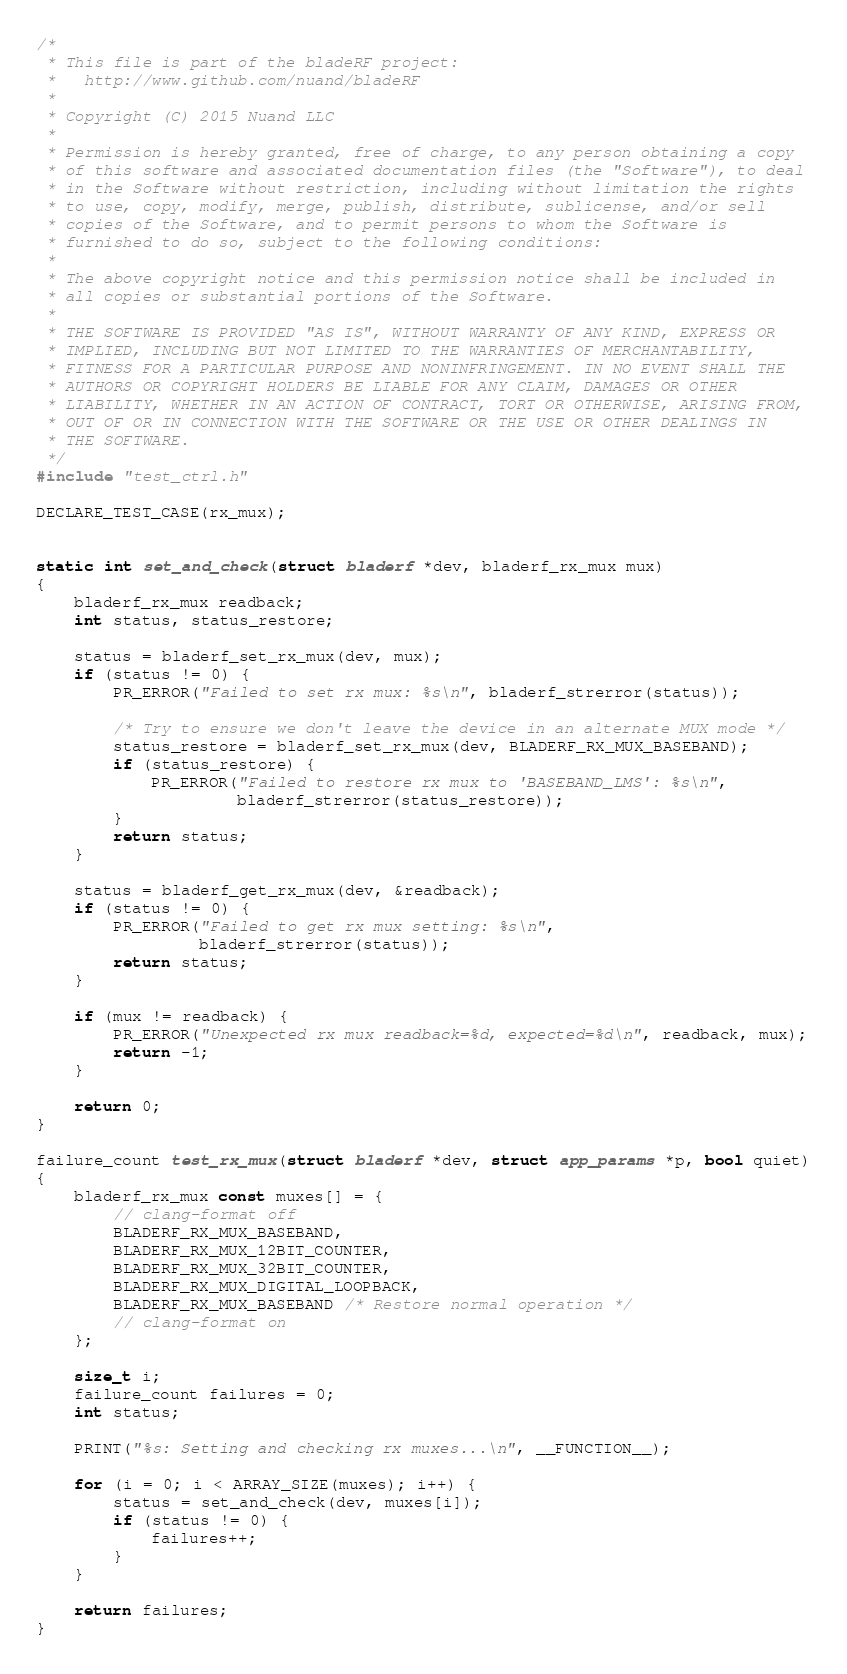<code> <loc_0><loc_0><loc_500><loc_500><_C_>/*
 * This file is part of the bladeRF project:
 *   http://www.github.com/nuand/bladeRF
 *
 * Copyright (C) 2015 Nuand LLC
 *
 * Permission is hereby granted, free of charge, to any person obtaining a copy
 * of this software and associated documentation files (the "Software"), to deal
 * in the Software without restriction, including without limitation the rights
 * to use, copy, modify, merge, publish, distribute, sublicense, and/or sell
 * copies of the Software, and to permit persons to whom the Software is
 * furnished to do so, subject to the following conditions:
 *
 * The above copyright notice and this permission notice shall be included in
 * all copies or substantial portions of the Software.
 *
 * THE SOFTWARE IS PROVIDED "AS IS", WITHOUT WARRANTY OF ANY KIND, EXPRESS OR
 * IMPLIED, INCLUDING BUT NOT LIMITED TO THE WARRANTIES OF MERCHANTABILITY,
 * FITNESS FOR A PARTICULAR PURPOSE AND NONINFRINGEMENT. IN NO EVENT SHALL THE
 * AUTHORS OR COPYRIGHT HOLDERS BE LIABLE FOR ANY CLAIM, DAMAGES OR OTHER
 * LIABILITY, WHETHER IN AN ACTION OF CONTRACT, TORT OR OTHERWISE, ARISING FROM,
 * OUT OF OR IN CONNECTION WITH THE SOFTWARE OR THE USE OR OTHER DEALINGS IN
 * THE SOFTWARE.
 */
#include "test_ctrl.h"

DECLARE_TEST_CASE(rx_mux);


static int set_and_check(struct bladerf *dev, bladerf_rx_mux mux)
{
    bladerf_rx_mux readback;
    int status, status_restore;

    status = bladerf_set_rx_mux(dev, mux);
    if (status != 0) {
        PR_ERROR("Failed to set rx mux: %s\n", bladerf_strerror(status));

        /* Try to ensure we don't leave the device in an alternate MUX mode */
        status_restore = bladerf_set_rx_mux(dev, BLADERF_RX_MUX_BASEBAND);
        if (status_restore) {
            PR_ERROR("Failed to restore rx mux to 'BASEBAND_LMS': %s\n",
                     bladerf_strerror(status_restore));
        }
        return status;
    }

    status = bladerf_get_rx_mux(dev, &readback);
    if (status != 0) {
        PR_ERROR("Failed to get rx mux setting: %s\n",
                 bladerf_strerror(status));
        return status;
    }

    if (mux != readback) {
        PR_ERROR("Unexpected rx mux readback=%d, expected=%d\n", readback, mux);
        return -1;
    }

    return 0;
}

failure_count test_rx_mux(struct bladerf *dev, struct app_params *p, bool quiet)
{
    bladerf_rx_mux const muxes[] = {
        // clang-format off
        BLADERF_RX_MUX_BASEBAND,
        BLADERF_RX_MUX_12BIT_COUNTER,
        BLADERF_RX_MUX_32BIT_COUNTER,
        BLADERF_RX_MUX_DIGITAL_LOOPBACK,
        BLADERF_RX_MUX_BASEBAND /* Restore normal operation */
        // clang-format on
    };

    size_t i;
    failure_count failures = 0;
    int status;

    PRINT("%s: Setting and checking rx muxes...\n", __FUNCTION__);

    for (i = 0; i < ARRAY_SIZE(muxes); i++) {
        status = set_and_check(dev, muxes[i]);
        if (status != 0) {
            failures++;
        }
    }

    return failures;
}
</code> 